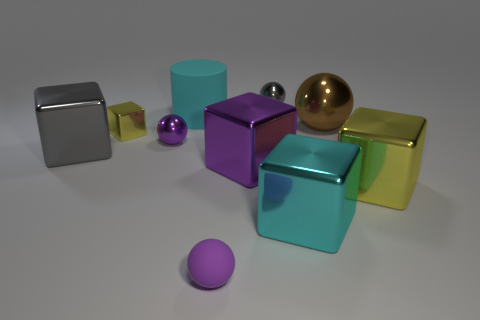The cyan rubber thing is what size?
Your response must be concise. Large. There is a cyan cylinder that is the same size as the purple block; what is its material?
Your response must be concise. Rubber. There is a rubber object behind the large purple object; what is its color?
Your answer should be very brief. Cyan. What number of brown shiny things are there?
Your answer should be compact. 1. There is a yellow metal object that is on the left side of the yellow metal cube on the right side of the brown metallic sphere; is there a big metallic object in front of it?
Ensure brevity in your answer.  Yes. What is the shape of the purple thing that is the same size as the brown ball?
Keep it short and to the point. Cube. How many other things are there of the same color as the large cylinder?
Offer a very short reply. 1. What is the big brown sphere made of?
Offer a terse response. Metal. How many other objects are the same material as the cylinder?
Give a very brief answer. 1. There is a ball that is to the right of the tiny purple rubber object and in front of the cylinder; how big is it?
Offer a very short reply. Large. 